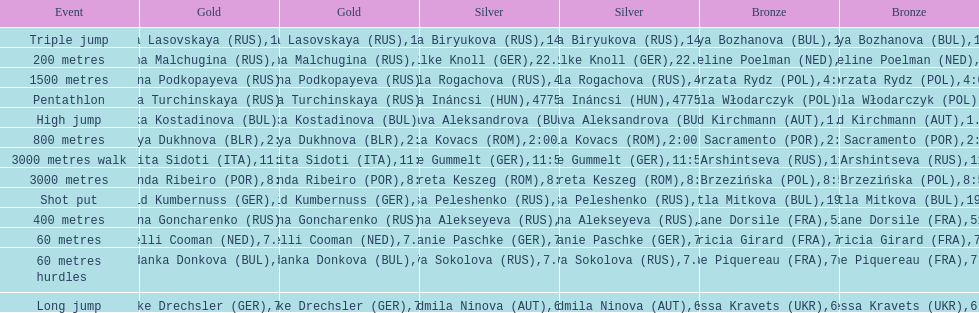How many german women won medals? 5. Would you be able to parse every entry in this table? {'header': ['Event', 'Gold', 'Gold', 'Silver', 'Silver', 'Bronze', 'Bronze'], 'rows': [['Triple jump', 'Inna Lasovskaya\xa0(RUS)', '14.88', 'Anna Biryukova\xa0(RUS)', '14.72', 'Sofiya Bozhanova\xa0(BUL)', '14.52'], ['200 metres', 'Galina Malchugina\xa0(RUS)', '22.41', 'Silke Knoll\xa0(GER)', '22.96', 'Jacqueline Poelman\xa0(NED)', '23.43'], ['1500 metres', 'Yekaterina Podkopayeva\xa0(RUS)', '4:06.46', 'Lyudmila Rogachova\xa0(RUS)', '4:06.60', 'Małgorzata Rydz\xa0(POL)', '4:06.98'], ['Pentathlon', 'Larisa Turchinskaya\xa0(RUS)', '4801', 'Rita Ináncsi\xa0(HUN)', '4775 NR', 'Urszula Włodarczyk\xa0(POL)', '4668'], ['High jump', 'Stefka Kostadinova\xa0(BUL)', '1.98', 'Desislava Aleksandrova\xa0(BUL)', '1.96', 'Sigrid Kirchmann\xa0(AUT)', '1.94 NR'], ['800 metres', 'Natalya Dukhnova\xa0(BLR)', '2:00.42', 'Ella Kovacs\xa0(ROM)', '2:00.49', 'Carla Sacramento\xa0(POR)', '2:01.12'], ['3000 metres walk', 'Annarita Sidoti\xa0(ITA)', '11:54.32', 'Beate Gummelt\xa0(GER)', '11:56.01', 'Yelena Arshintseva\xa0(RUS)', '11:57.48'], ['3000 metres', 'Fernanda Ribeiro\xa0(POR)', '8:50.47', 'Margareta Keszeg\xa0(ROM)', '8:55.61', 'Anna Brzezińska\xa0(POL)', '8:56.90'], ['Shot put', 'Astrid Kumbernuss\xa0(GER)', '19.44', 'Larisa Peleshenko\xa0(RUS)', '19.16', 'Svetla Mitkova\xa0(BUL)', '19.09'], ['400 metres', 'Svetlana Goncharenko\xa0(RUS)', '51.62', 'Tatyana Alekseyeva\xa0(RUS)', '51.77', 'Viviane Dorsile\xa0(FRA)', '51.92'], ['60 metres', 'Nelli Cooman\xa0(NED)', '7.17', 'Melanie Paschke\xa0(GER)', '7.19', 'Patricia Girard\xa0(FRA)', '7.19'], ['60 metres hurdles', 'Yordanka Donkova\xa0(BUL)', '7.85', 'Eva Sokolova\xa0(RUS)', '7.89', 'Anne Piquereau\xa0(FRA)', '7.91'], ['Long jump', 'Heike Drechsler\xa0(GER)', '7.06', 'Ljudmila Ninova\xa0(AUT)', '6.78', 'Inessa Kravets\xa0(UKR)', '6.72']]} 